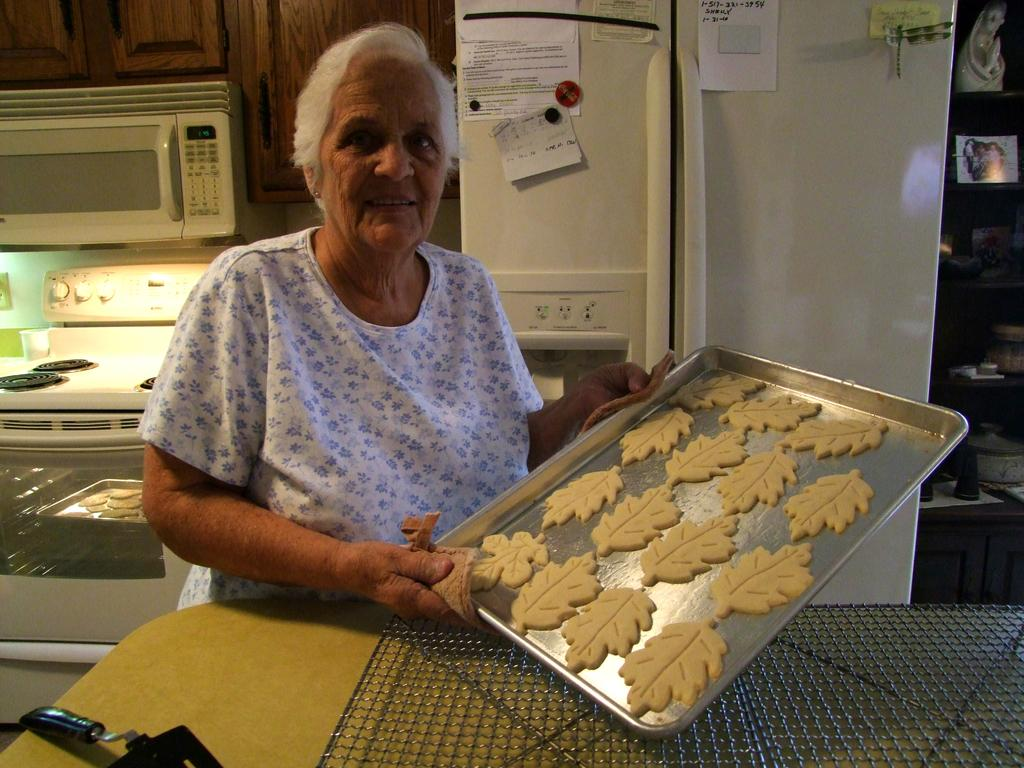What type of room might the image be taken in? The image might be taken in a kitchen. What appliances can be seen on the left side of the image? There is an oven and a stove on the left side of the image. What large appliance is located in the middle of the image? There is a refrigerator in the middle of the image. What is the person in the image holding? The person is holding a plate. What type of mine can be seen in the image? There is no mine present in the image; it appears to be taken in a kitchen. What color is the feather on the person's head in the image? There is no feather present on the person's head in the image. 